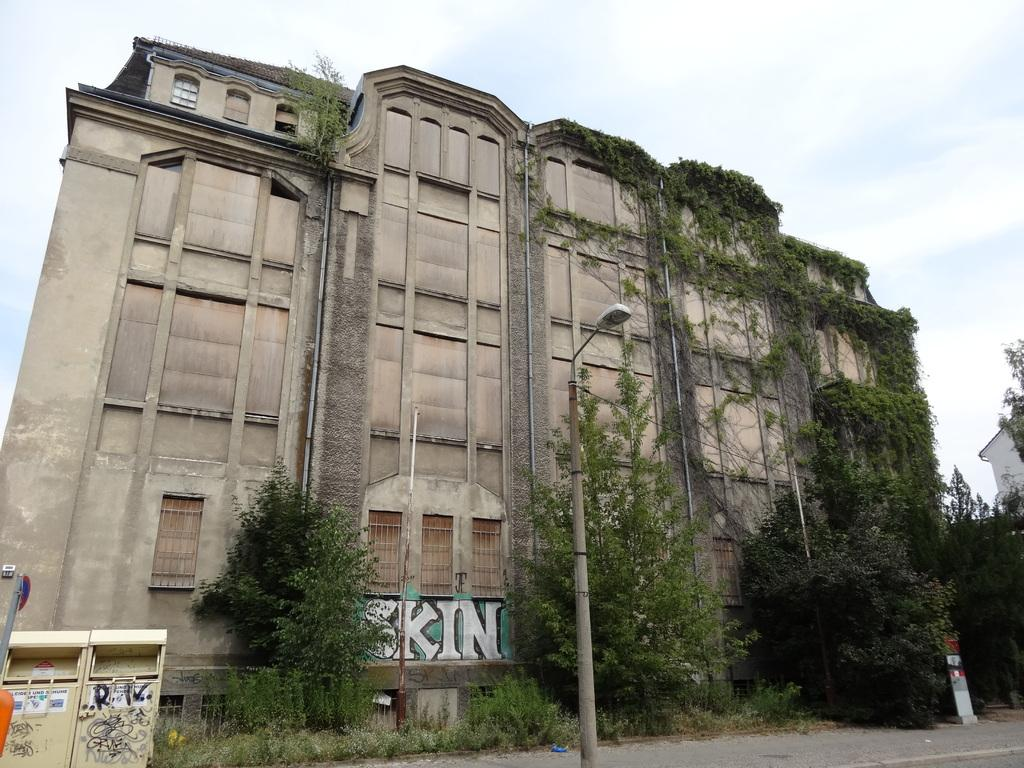What type of structure is visible in the image? There is a building with windows in the image. What can be seen illuminating the street in the image? There is a street light in the image. What type of vegetation is visible in the image? Trees and plants are visible in the image. What is located at the bottom left side of the image? There is an object at the bottom left side of the image. What is visible in the background of the image? The sky is visible in the image. Can you tell me how many kittens are playing with a match in the image? There are no kittens or matches present in the image. What type of cover is used to protect the plants in the image? There is no cover visible in the image; only plants are present. 